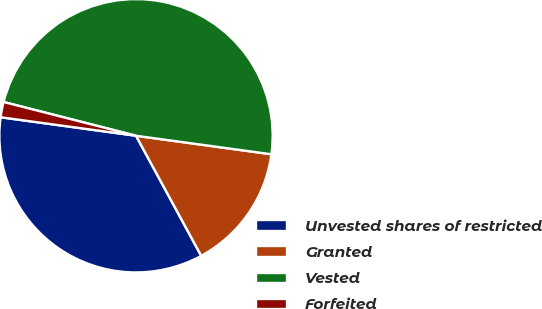Convert chart. <chart><loc_0><loc_0><loc_500><loc_500><pie_chart><fcel>Unvested shares of restricted<fcel>Granted<fcel>Vested<fcel>Forfeited<nl><fcel>35.08%<fcel>14.92%<fcel>48.19%<fcel>1.81%<nl></chart> 